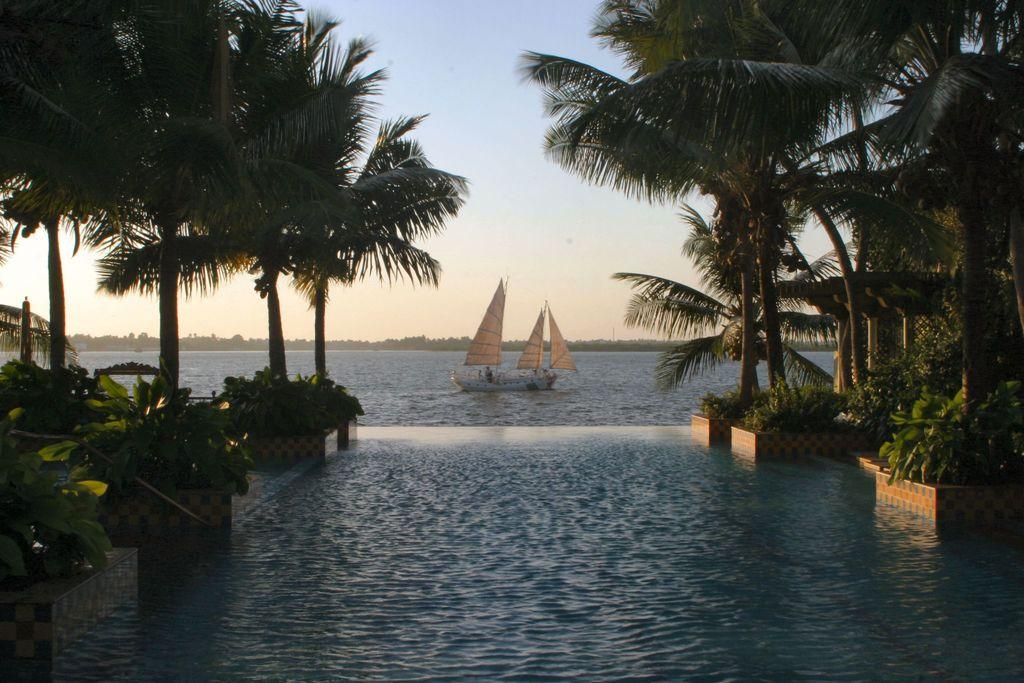What type of vegetation can be seen in the image? There are plants and trees in the image. What is the primary element visible in the image? Water is visible in the image. What is located on the water in the image? There is a boat in the image. What can be seen in the background of the image? The sky is visible in the background of the image. What type of record is being played in the image? There is no record present in the image; it features plants, trees, water, a boat, and the sky. What smell can be detected from the plants in the image? The image does not provide information about the smell of the plants, as it is a visual representation. 